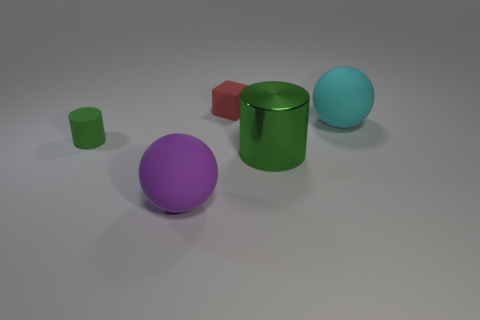Add 4 large green objects. How many objects exist? 9 Subtract all cubes. How many objects are left? 4 Subtract 0 blue cubes. How many objects are left? 5 Subtract all small cylinders. Subtract all large purple objects. How many objects are left? 3 Add 1 big purple matte things. How many big purple matte things are left? 2 Add 1 large gray spheres. How many large gray spheres exist? 1 